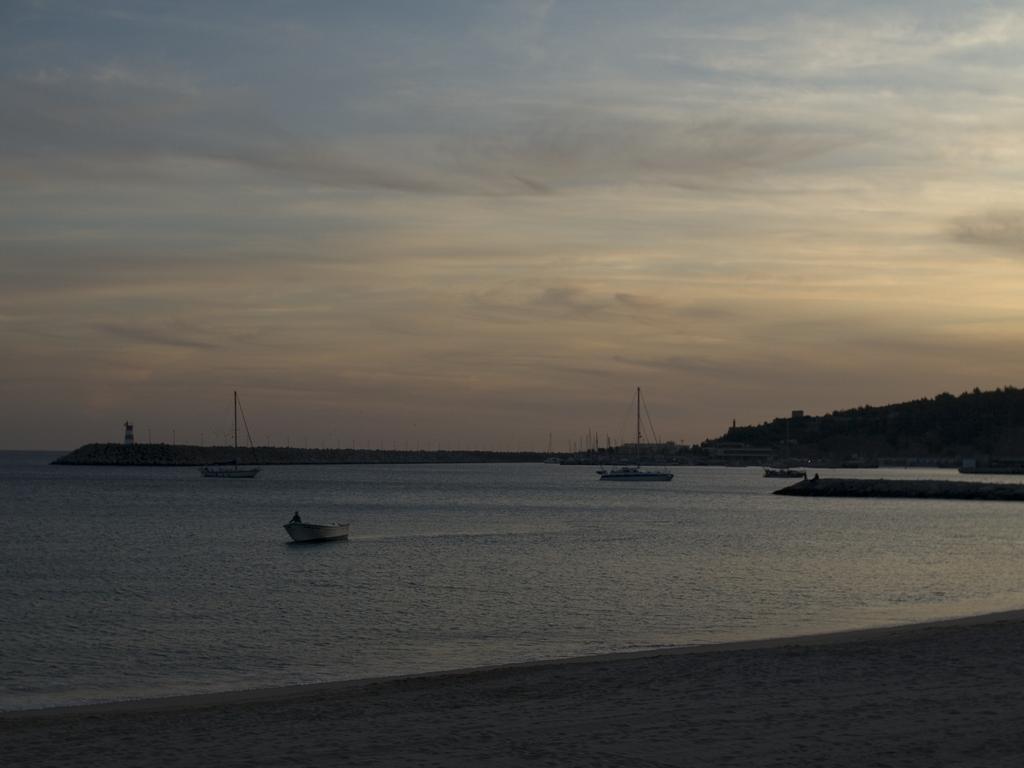In one or two sentences, can you explain what this image depicts? In this picture there are few boats on the water and there are few trees in the right corner. 